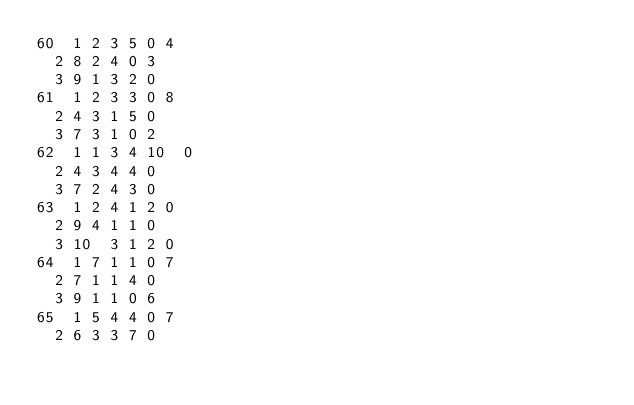Convert code to text. <code><loc_0><loc_0><loc_500><loc_500><_ObjectiveC_>60	1	2	3	5	0	4	
	2	8	2	4	0	3	
	3	9	1	3	2	0	
61	1	2	3	3	0	8	
	2	4	3	1	5	0	
	3	7	3	1	0	2	
62	1	1	3	4	10	0	
	2	4	3	4	4	0	
	3	7	2	4	3	0	
63	1	2	4	1	2	0	
	2	9	4	1	1	0	
	3	10	3	1	2	0	
64	1	7	1	1	0	7	
	2	7	1	1	4	0	
	3	9	1	1	0	6	
65	1	5	4	4	0	7	
	2	6	3	3	7	0	</code> 